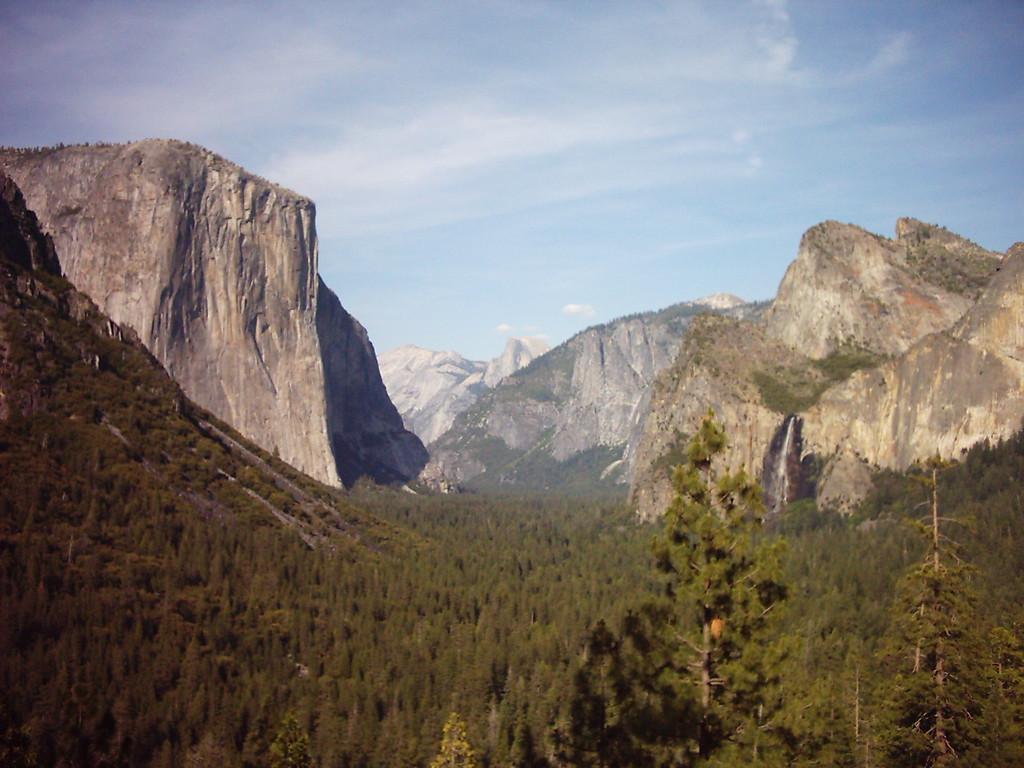Please provide a concise description of this image. In this image we can see trees, hills, sky and clouds. 